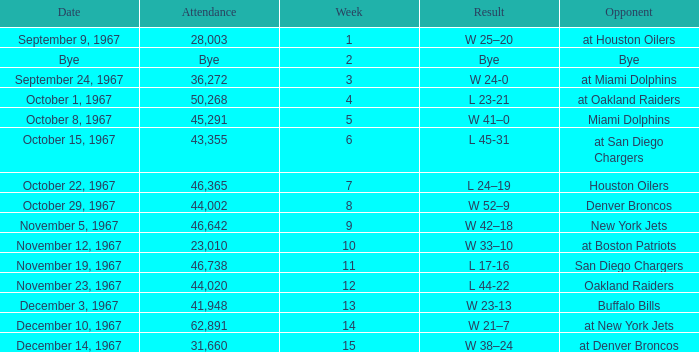What was the date of the game after week 5 against the Houston Oilers? October 22, 1967. 